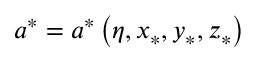<formula> <loc_0><loc_0><loc_500><loc_500>a ^ { \ast } = a ^ { \ast } \left ( \eta , x _ { \ast } , y _ { \ast } , z _ { \ast } \right )</formula> 